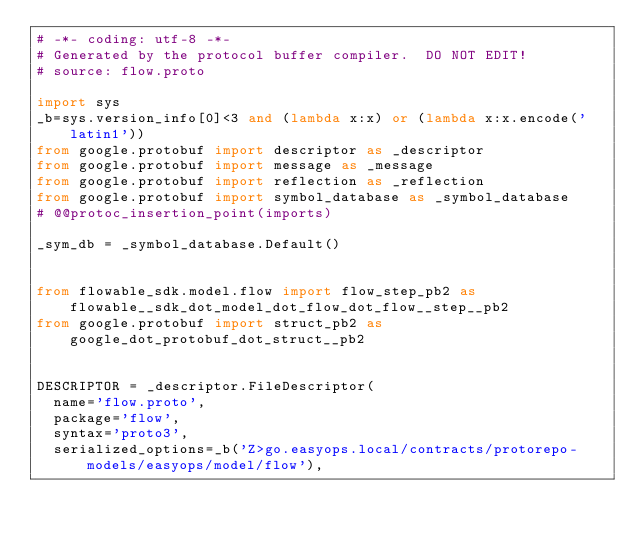Convert code to text. <code><loc_0><loc_0><loc_500><loc_500><_Python_># -*- coding: utf-8 -*-
# Generated by the protocol buffer compiler.  DO NOT EDIT!
# source: flow.proto

import sys
_b=sys.version_info[0]<3 and (lambda x:x) or (lambda x:x.encode('latin1'))
from google.protobuf import descriptor as _descriptor
from google.protobuf import message as _message
from google.protobuf import reflection as _reflection
from google.protobuf import symbol_database as _symbol_database
# @@protoc_insertion_point(imports)

_sym_db = _symbol_database.Default()


from flowable_sdk.model.flow import flow_step_pb2 as flowable__sdk_dot_model_dot_flow_dot_flow__step__pb2
from google.protobuf import struct_pb2 as google_dot_protobuf_dot_struct__pb2


DESCRIPTOR = _descriptor.FileDescriptor(
  name='flow.proto',
  package='flow',
  syntax='proto3',
  serialized_options=_b('Z>go.easyops.local/contracts/protorepo-models/easyops/model/flow'),</code> 